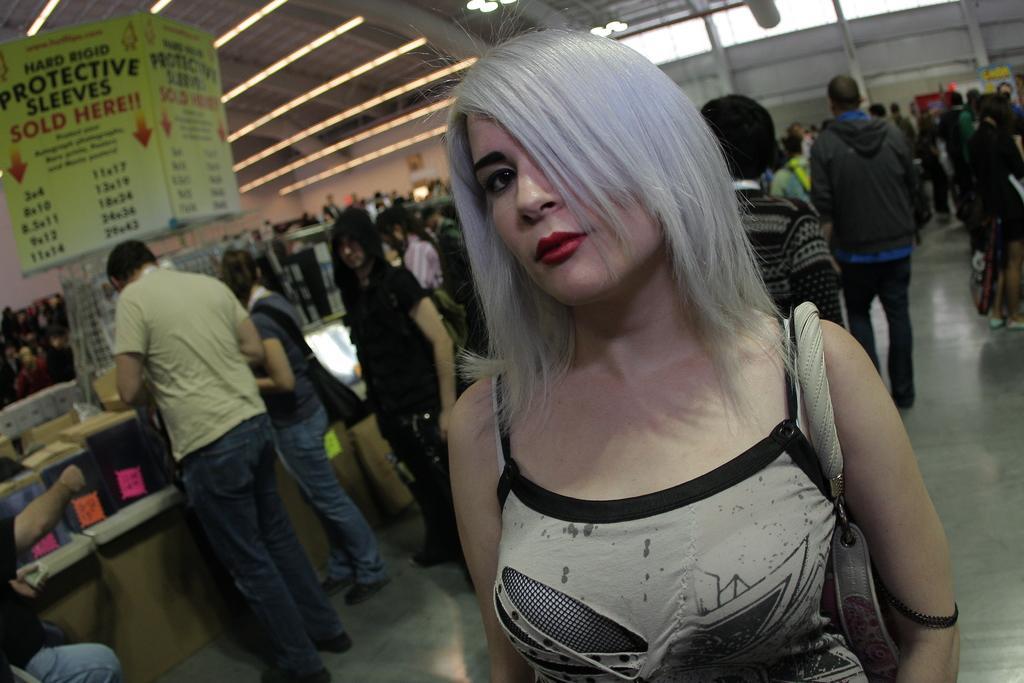Could you give a brief overview of what you see in this image? In this image we can see a lady holding a bag. In the back there are many people. Also there are boxes on surface. And there are banners. On the ceiling there are lights. In the background there is a wall. 